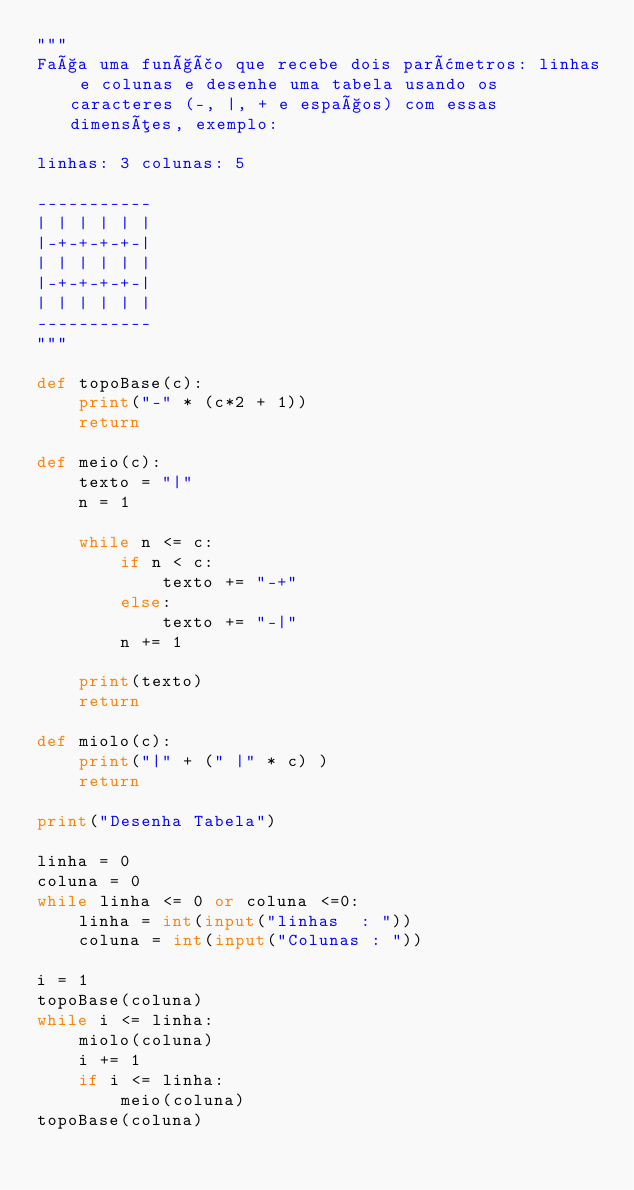Convert code to text. <code><loc_0><loc_0><loc_500><loc_500><_Python_>"""
Faça uma função que recebe dois parâmetros: linhas e colunas e desenhe uma tabela usando os caracteres (-, |, + e espaços) com essas dimensões, exemplo:

linhas: 3 colunas: 5

-----------
| | | | | |
|-+-+-+-+-|
| | | | | |
|-+-+-+-+-|
| | | | | |
-----------
"""

def topoBase(c):
    print("-" * (c*2 + 1))
    return

def meio(c):
    texto = "|"
    n = 1    
    
    while n <= c:
        if n < c:
            texto += "-+"
        else:
            texto += "-|" 
        n += 1    
        
    print(texto)
    return

def miolo(c):
    print("|" + (" |" * c) )
    return

print("Desenha Tabela")

linha = 0
coluna = 0
while linha <= 0 or coluna <=0:
    linha = int(input("linhas  : "))
    coluna = int(input("Colunas : "))
    
i = 1
topoBase(coluna)   
while i <= linha:
    miolo(coluna) 
    i += 1
    if i <= linha:
        meio(coluna)
topoBase(coluna)    
</code> 